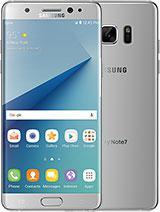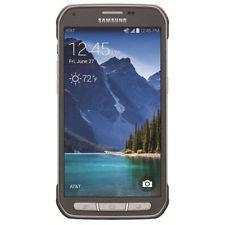The first image is the image on the left, the second image is the image on the right. Examine the images to the left and right. Is the description "The back of a phone is visible." accurate? Answer yes or no. Yes. The first image is the image on the left, the second image is the image on the right. Given the left and right images, does the statement "The image on the left shows one smartphone, face up on a wood table." hold true? Answer yes or no. No. 